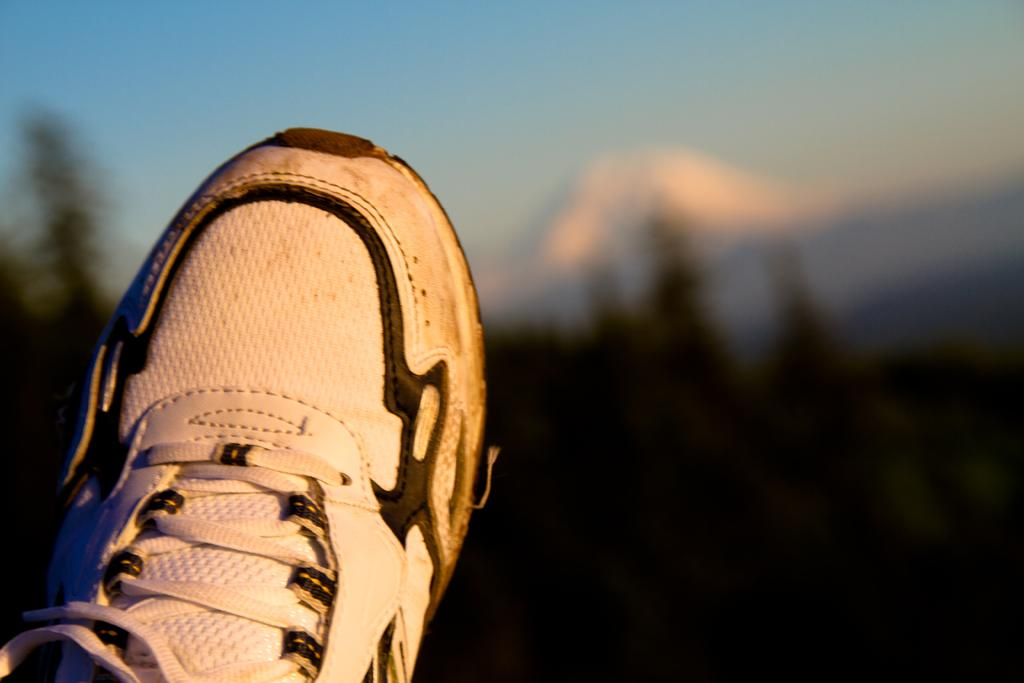What object can be seen in the image? There is a shoe in the image. What colors are present on the shoe? The shoe is white and black in color. What can be seen in the background of the image? There is a blue sky visible in the image. What type of vegetation is present in the image? There are trees in the image. What type of art is displayed on the shoe in the image? There is no art displayed on the shoe in the image; it is a simple white and black shoe. What riddle can be solved using the information provided in the image? There is no riddle present in the image; it is a straightforward depiction of a shoe and its surroundings. 